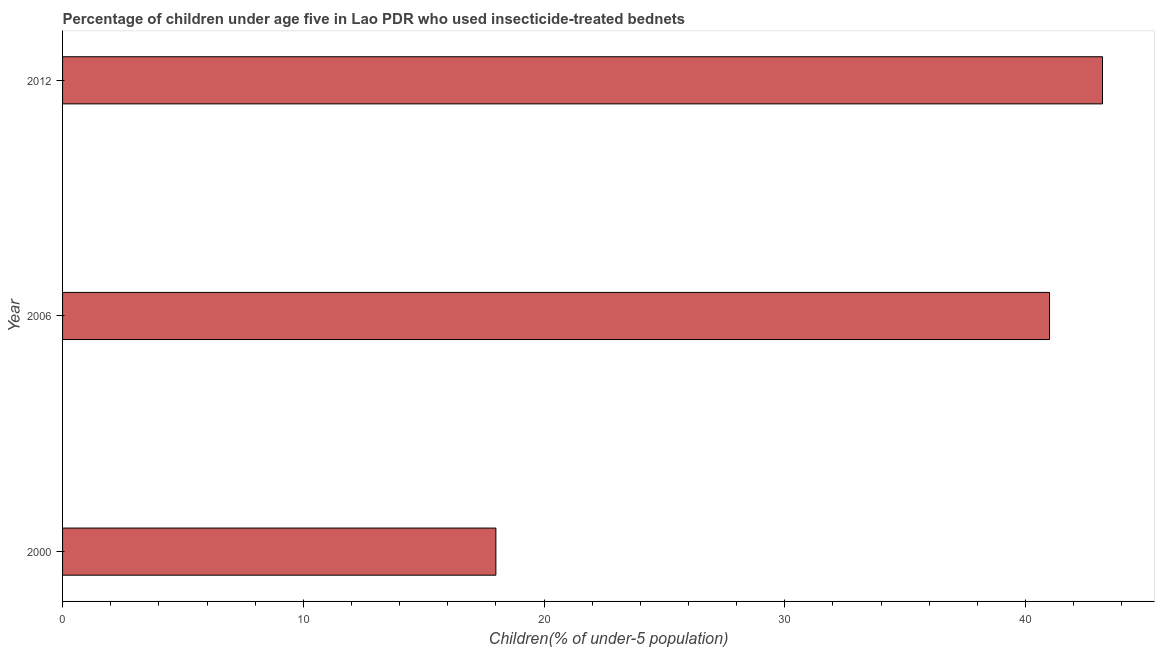Does the graph contain any zero values?
Offer a very short reply. No. What is the title of the graph?
Give a very brief answer. Percentage of children under age five in Lao PDR who used insecticide-treated bednets. What is the label or title of the X-axis?
Keep it short and to the point. Children(% of under-5 population). Across all years, what is the maximum percentage of children who use of insecticide-treated bed nets?
Your response must be concise. 43.2. In which year was the percentage of children who use of insecticide-treated bed nets minimum?
Your answer should be very brief. 2000. What is the sum of the percentage of children who use of insecticide-treated bed nets?
Ensure brevity in your answer.  102.2. What is the average percentage of children who use of insecticide-treated bed nets per year?
Offer a very short reply. 34.07. In how many years, is the percentage of children who use of insecticide-treated bed nets greater than 24 %?
Give a very brief answer. 2. Do a majority of the years between 2000 and 2012 (inclusive) have percentage of children who use of insecticide-treated bed nets greater than 42 %?
Offer a terse response. No. What is the ratio of the percentage of children who use of insecticide-treated bed nets in 2000 to that in 2006?
Provide a succinct answer. 0.44. Is the percentage of children who use of insecticide-treated bed nets in 2006 less than that in 2012?
Provide a short and direct response. Yes. What is the difference between the highest and the lowest percentage of children who use of insecticide-treated bed nets?
Your response must be concise. 25.2. Are all the bars in the graph horizontal?
Make the answer very short. Yes. How many years are there in the graph?
Offer a terse response. 3. What is the difference between two consecutive major ticks on the X-axis?
Give a very brief answer. 10. What is the Children(% of under-5 population) in 2000?
Ensure brevity in your answer.  18. What is the Children(% of under-5 population) of 2006?
Keep it short and to the point. 41. What is the Children(% of under-5 population) in 2012?
Provide a short and direct response. 43.2. What is the difference between the Children(% of under-5 population) in 2000 and 2006?
Offer a very short reply. -23. What is the difference between the Children(% of under-5 population) in 2000 and 2012?
Your response must be concise. -25.2. What is the difference between the Children(% of under-5 population) in 2006 and 2012?
Keep it short and to the point. -2.2. What is the ratio of the Children(% of under-5 population) in 2000 to that in 2006?
Your answer should be compact. 0.44. What is the ratio of the Children(% of under-5 population) in 2000 to that in 2012?
Your answer should be very brief. 0.42. What is the ratio of the Children(% of under-5 population) in 2006 to that in 2012?
Provide a short and direct response. 0.95. 